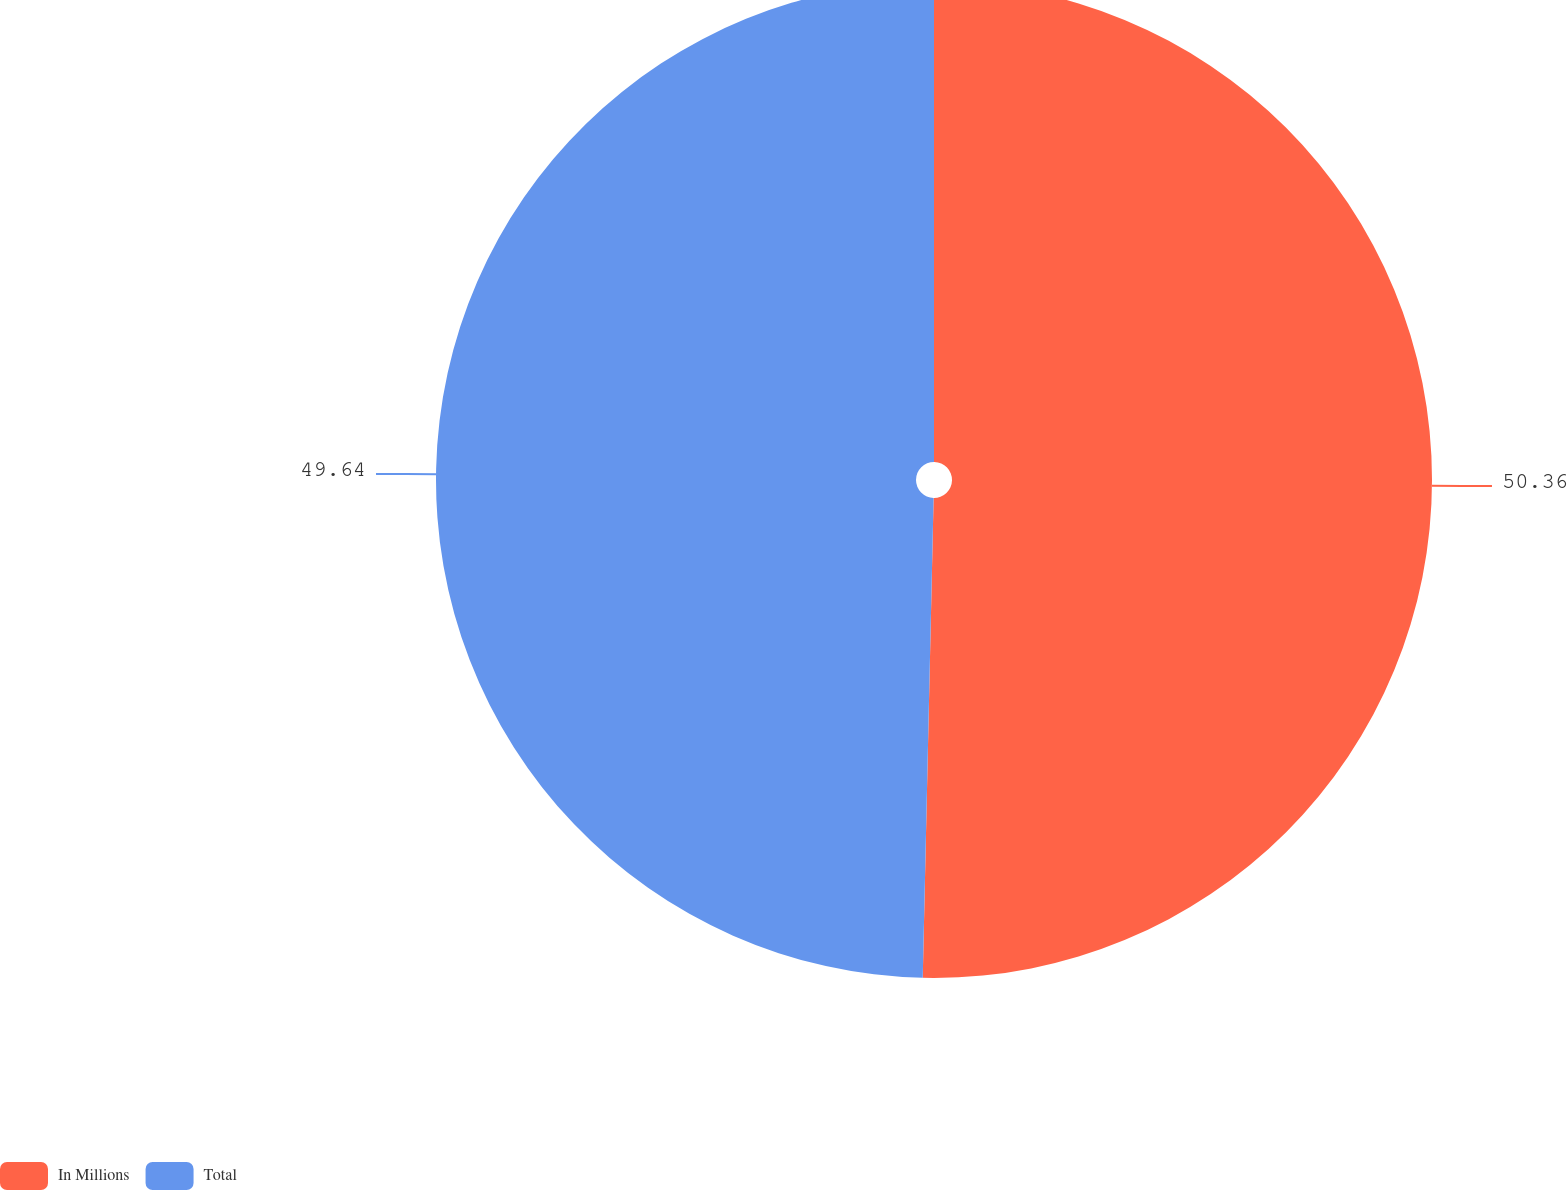Convert chart. <chart><loc_0><loc_0><loc_500><loc_500><pie_chart><fcel>In Millions<fcel>Total<nl><fcel>50.36%<fcel>49.64%<nl></chart> 